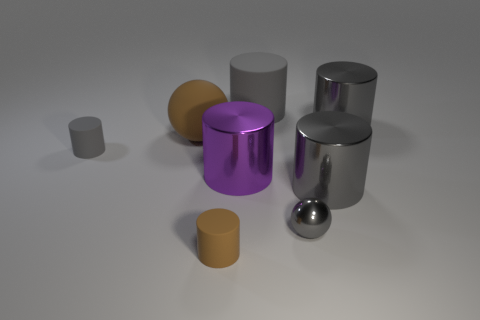What is the shape of the large brown object?
Offer a very short reply. Sphere. What is the shape of the gray matte thing that is the same size as the brown rubber sphere?
Provide a succinct answer. Cylinder. Is there anything else that has the same color as the small sphere?
Your answer should be compact. Yes. The purple cylinder that is the same material as the tiny sphere is what size?
Keep it short and to the point. Large. There is a tiny gray metal object; does it have the same shape as the brown rubber object behind the tiny gray shiny ball?
Offer a very short reply. Yes. What size is the metal ball?
Keep it short and to the point. Small. Is the number of gray metal things on the left side of the small gray ball less than the number of tiny gray cylinders?
Ensure brevity in your answer.  Yes. What number of brown cylinders have the same size as the purple thing?
Your response must be concise. 0. What is the shape of the small rubber thing that is the same color as the big sphere?
Your answer should be very brief. Cylinder. There is a small rubber thing that is to the left of the big brown ball; is it the same color as the big rubber thing that is on the right side of the purple cylinder?
Offer a very short reply. Yes. 